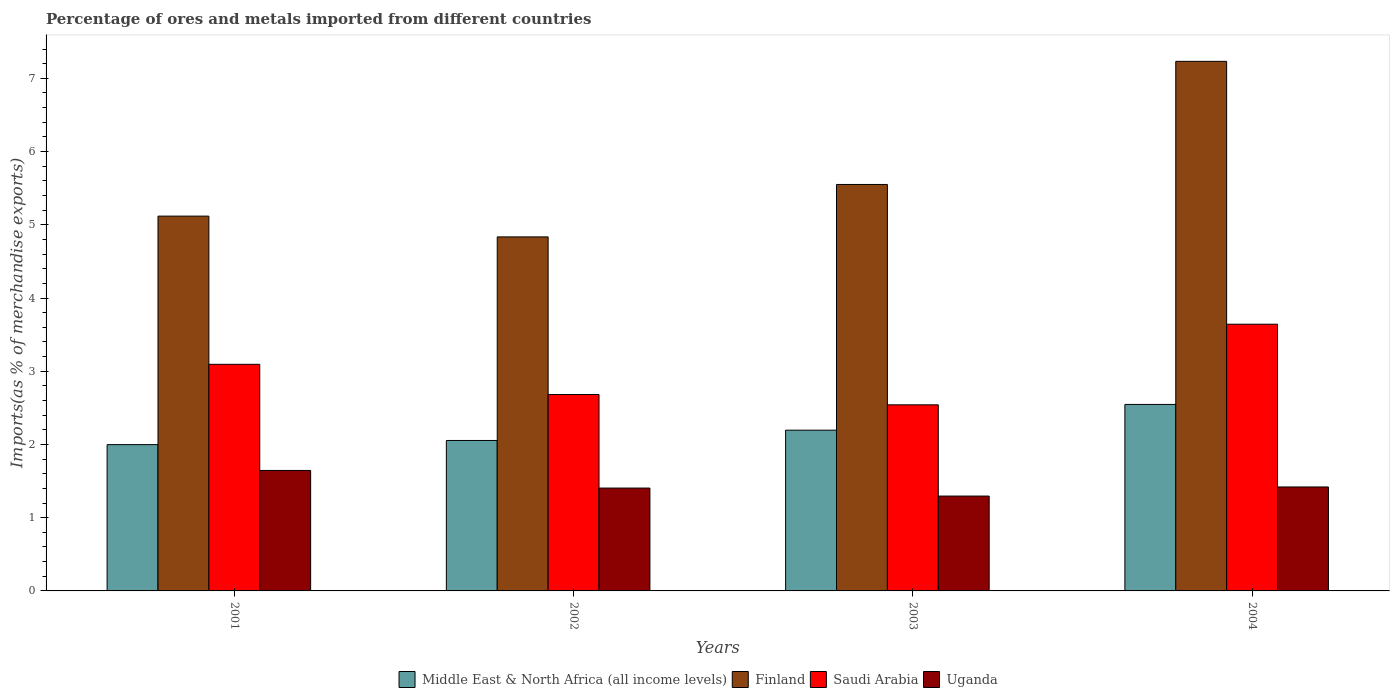How many bars are there on the 3rd tick from the left?
Your response must be concise. 4. What is the percentage of imports to different countries in Uganda in 2004?
Provide a succinct answer. 1.42. Across all years, what is the maximum percentage of imports to different countries in Finland?
Your answer should be very brief. 7.23. Across all years, what is the minimum percentage of imports to different countries in Middle East & North Africa (all income levels)?
Provide a succinct answer. 2. In which year was the percentage of imports to different countries in Finland maximum?
Your answer should be compact. 2004. In which year was the percentage of imports to different countries in Uganda minimum?
Your answer should be very brief. 2003. What is the total percentage of imports to different countries in Finland in the graph?
Ensure brevity in your answer.  22.74. What is the difference between the percentage of imports to different countries in Uganda in 2001 and that in 2003?
Ensure brevity in your answer.  0.35. What is the difference between the percentage of imports to different countries in Middle East & North Africa (all income levels) in 2003 and the percentage of imports to different countries in Uganda in 2002?
Offer a very short reply. 0.79. What is the average percentage of imports to different countries in Saudi Arabia per year?
Offer a terse response. 2.99. In the year 2003, what is the difference between the percentage of imports to different countries in Uganda and percentage of imports to different countries in Middle East & North Africa (all income levels)?
Ensure brevity in your answer.  -0.9. What is the ratio of the percentage of imports to different countries in Uganda in 2001 to that in 2003?
Provide a succinct answer. 1.27. Is the difference between the percentage of imports to different countries in Uganda in 2003 and 2004 greater than the difference between the percentage of imports to different countries in Middle East & North Africa (all income levels) in 2003 and 2004?
Make the answer very short. Yes. What is the difference between the highest and the second highest percentage of imports to different countries in Finland?
Provide a succinct answer. 1.68. What is the difference between the highest and the lowest percentage of imports to different countries in Uganda?
Your answer should be compact. 0.35. In how many years, is the percentage of imports to different countries in Finland greater than the average percentage of imports to different countries in Finland taken over all years?
Offer a terse response. 1. What does the 4th bar from the left in 2001 represents?
Provide a succinct answer. Uganda. What does the 2nd bar from the right in 2004 represents?
Your answer should be compact. Saudi Arabia. Is it the case that in every year, the sum of the percentage of imports to different countries in Saudi Arabia and percentage of imports to different countries in Uganda is greater than the percentage of imports to different countries in Finland?
Keep it short and to the point. No. How many bars are there?
Your answer should be very brief. 16. What is the difference between two consecutive major ticks on the Y-axis?
Provide a short and direct response. 1. Does the graph contain any zero values?
Your answer should be very brief. No. How are the legend labels stacked?
Make the answer very short. Horizontal. What is the title of the graph?
Your answer should be very brief. Percentage of ores and metals imported from different countries. What is the label or title of the X-axis?
Your answer should be compact. Years. What is the label or title of the Y-axis?
Provide a short and direct response. Imports(as % of merchandise exports). What is the Imports(as % of merchandise exports) in Middle East & North Africa (all income levels) in 2001?
Provide a short and direct response. 2. What is the Imports(as % of merchandise exports) of Finland in 2001?
Your response must be concise. 5.12. What is the Imports(as % of merchandise exports) of Saudi Arabia in 2001?
Ensure brevity in your answer.  3.09. What is the Imports(as % of merchandise exports) in Uganda in 2001?
Offer a very short reply. 1.65. What is the Imports(as % of merchandise exports) of Middle East & North Africa (all income levels) in 2002?
Your answer should be very brief. 2.05. What is the Imports(as % of merchandise exports) of Finland in 2002?
Your answer should be compact. 4.83. What is the Imports(as % of merchandise exports) in Saudi Arabia in 2002?
Keep it short and to the point. 2.68. What is the Imports(as % of merchandise exports) in Uganda in 2002?
Your response must be concise. 1.4. What is the Imports(as % of merchandise exports) of Middle East & North Africa (all income levels) in 2003?
Provide a short and direct response. 2.2. What is the Imports(as % of merchandise exports) in Finland in 2003?
Your answer should be very brief. 5.55. What is the Imports(as % of merchandise exports) in Saudi Arabia in 2003?
Offer a terse response. 2.54. What is the Imports(as % of merchandise exports) of Uganda in 2003?
Your answer should be very brief. 1.3. What is the Imports(as % of merchandise exports) of Middle East & North Africa (all income levels) in 2004?
Offer a terse response. 2.55. What is the Imports(as % of merchandise exports) in Finland in 2004?
Your answer should be compact. 7.23. What is the Imports(as % of merchandise exports) of Saudi Arabia in 2004?
Your answer should be compact. 3.64. What is the Imports(as % of merchandise exports) of Uganda in 2004?
Keep it short and to the point. 1.42. Across all years, what is the maximum Imports(as % of merchandise exports) in Middle East & North Africa (all income levels)?
Your response must be concise. 2.55. Across all years, what is the maximum Imports(as % of merchandise exports) of Finland?
Your answer should be very brief. 7.23. Across all years, what is the maximum Imports(as % of merchandise exports) in Saudi Arabia?
Give a very brief answer. 3.64. Across all years, what is the maximum Imports(as % of merchandise exports) of Uganda?
Your answer should be compact. 1.65. Across all years, what is the minimum Imports(as % of merchandise exports) in Middle East & North Africa (all income levels)?
Make the answer very short. 2. Across all years, what is the minimum Imports(as % of merchandise exports) of Finland?
Your answer should be very brief. 4.83. Across all years, what is the minimum Imports(as % of merchandise exports) of Saudi Arabia?
Your response must be concise. 2.54. Across all years, what is the minimum Imports(as % of merchandise exports) in Uganda?
Your response must be concise. 1.3. What is the total Imports(as % of merchandise exports) of Middle East & North Africa (all income levels) in the graph?
Ensure brevity in your answer.  8.79. What is the total Imports(as % of merchandise exports) of Finland in the graph?
Give a very brief answer. 22.74. What is the total Imports(as % of merchandise exports) of Saudi Arabia in the graph?
Your answer should be very brief. 11.96. What is the total Imports(as % of merchandise exports) of Uganda in the graph?
Make the answer very short. 5.76. What is the difference between the Imports(as % of merchandise exports) of Middle East & North Africa (all income levels) in 2001 and that in 2002?
Your response must be concise. -0.06. What is the difference between the Imports(as % of merchandise exports) of Finland in 2001 and that in 2002?
Keep it short and to the point. 0.28. What is the difference between the Imports(as % of merchandise exports) in Saudi Arabia in 2001 and that in 2002?
Provide a succinct answer. 0.41. What is the difference between the Imports(as % of merchandise exports) of Uganda in 2001 and that in 2002?
Keep it short and to the point. 0.24. What is the difference between the Imports(as % of merchandise exports) of Middle East & North Africa (all income levels) in 2001 and that in 2003?
Give a very brief answer. -0.2. What is the difference between the Imports(as % of merchandise exports) in Finland in 2001 and that in 2003?
Your response must be concise. -0.43. What is the difference between the Imports(as % of merchandise exports) in Saudi Arabia in 2001 and that in 2003?
Your answer should be very brief. 0.55. What is the difference between the Imports(as % of merchandise exports) of Middle East & North Africa (all income levels) in 2001 and that in 2004?
Keep it short and to the point. -0.55. What is the difference between the Imports(as % of merchandise exports) of Finland in 2001 and that in 2004?
Offer a very short reply. -2.11. What is the difference between the Imports(as % of merchandise exports) in Saudi Arabia in 2001 and that in 2004?
Ensure brevity in your answer.  -0.55. What is the difference between the Imports(as % of merchandise exports) of Uganda in 2001 and that in 2004?
Give a very brief answer. 0.23. What is the difference between the Imports(as % of merchandise exports) in Middle East & North Africa (all income levels) in 2002 and that in 2003?
Make the answer very short. -0.14. What is the difference between the Imports(as % of merchandise exports) in Finland in 2002 and that in 2003?
Provide a succinct answer. -0.72. What is the difference between the Imports(as % of merchandise exports) in Saudi Arabia in 2002 and that in 2003?
Make the answer very short. 0.14. What is the difference between the Imports(as % of merchandise exports) of Uganda in 2002 and that in 2003?
Ensure brevity in your answer.  0.11. What is the difference between the Imports(as % of merchandise exports) in Middle East & North Africa (all income levels) in 2002 and that in 2004?
Keep it short and to the point. -0.49. What is the difference between the Imports(as % of merchandise exports) of Finland in 2002 and that in 2004?
Ensure brevity in your answer.  -2.4. What is the difference between the Imports(as % of merchandise exports) of Saudi Arabia in 2002 and that in 2004?
Your answer should be compact. -0.96. What is the difference between the Imports(as % of merchandise exports) in Uganda in 2002 and that in 2004?
Offer a very short reply. -0.02. What is the difference between the Imports(as % of merchandise exports) of Middle East & North Africa (all income levels) in 2003 and that in 2004?
Offer a very short reply. -0.35. What is the difference between the Imports(as % of merchandise exports) in Finland in 2003 and that in 2004?
Provide a short and direct response. -1.68. What is the difference between the Imports(as % of merchandise exports) of Saudi Arabia in 2003 and that in 2004?
Your answer should be compact. -1.1. What is the difference between the Imports(as % of merchandise exports) of Uganda in 2003 and that in 2004?
Offer a terse response. -0.12. What is the difference between the Imports(as % of merchandise exports) in Middle East & North Africa (all income levels) in 2001 and the Imports(as % of merchandise exports) in Finland in 2002?
Your answer should be compact. -2.84. What is the difference between the Imports(as % of merchandise exports) in Middle East & North Africa (all income levels) in 2001 and the Imports(as % of merchandise exports) in Saudi Arabia in 2002?
Keep it short and to the point. -0.68. What is the difference between the Imports(as % of merchandise exports) of Middle East & North Africa (all income levels) in 2001 and the Imports(as % of merchandise exports) of Uganda in 2002?
Make the answer very short. 0.59. What is the difference between the Imports(as % of merchandise exports) in Finland in 2001 and the Imports(as % of merchandise exports) in Saudi Arabia in 2002?
Your response must be concise. 2.44. What is the difference between the Imports(as % of merchandise exports) in Finland in 2001 and the Imports(as % of merchandise exports) in Uganda in 2002?
Provide a short and direct response. 3.71. What is the difference between the Imports(as % of merchandise exports) of Saudi Arabia in 2001 and the Imports(as % of merchandise exports) of Uganda in 2002?
Offer a very short reply. 1.69. What is the difference between the Imports(as % of merchandise exports) in Middle East & North Africa (all income levels) in 2001 and the Imports(as % of merchandise exports) in Finland in 2003?
Ensure brevity in your answer.  -3.55. What is the difference between the Imports(as % of merchandise exports) of Middle East & North Africa (all income levels) in 2001 and the Imports(as % of merchandise exports) of Saudi Arabia in 2003?
Your answer should be compact. -0.54. What is the difference between the Imports(as % of merchandise exports) in Middle East & North Africa (all income levels) in 2001 and the Imports(as % of merchandise exports) in Uganda in 2003?
Your answer should be compact. 0.7. What is the difference between the Imports(as % of merchandise exports) of Finland in 2001 and the Imports(as % of merchandise exports) of Saudi Arabia in 2003?
Offer a terse response. 2.58. What is the difference between the Imports(as % of merchandise exports) of Finland in 2001 and the Imports(as % of merchandise exports) of Uganda in 2003?
Offer a very short reply. 3.82. What is the difference between the Imports(as % of merchandise exports) in Saudi Arabia in 2001 and the Imports(as % of merchandise exports) in Uganda in 2003?
Offer a very short reply. 1.8. What is the difference between the Imports(as % of merchandise exports) in Middle East & North Africa (all income levels) in 2001 and the Imports(as % of merchandise exports) in Finland in 2004?
Give a very brief answer. -5.23. What is the difference between the Imports(as % of merchandise exports) in Middle East & North Africa (all income levels) in 2001 and the Imports(as % of merchandise exports) in Saudi Arabia in 2004?
Offer a terse response. -1.64. What is the difference between the Imports(as % of merchandise exports) of Middle East & North Africa (all income levels) in 2001 and the Imports(as % of merchandise exports) of Uganda in 2004?
Offer a terse response. 0.58. What is the difference between the Imports(as % of merchandise exports) in Finland in 2001 and the Imports(as % of merchandise exports) in Saudi Arabia in 2004?
Ensure brevity in your answer.  1.48. What is the difference between the Imports(as % of merchandise exports) in Finland in 2001 and the Imports(as % of merchandise exports) in Uganda in 2004?
Keep it short and to the point. 3.7. What is the difference between the Imports(as % of merchandise exports) in Saudi Arabia in 2001 and the Imports(as % of merchandise exports) in Uganda in 2004?
Your response must be concise. 1.67. What is the difference between the Imports(as % of merchandise exports) of Middle East & North Africa (all income levels) in 2002 and the Imports(as % of merchandise exports) of Finland in 2003?
Provide a succinct answer. -3.5. What is the difference between the Imports(as % of merchandise exports) in Middle East & North Africa (all income levels) in 2002 and the Imports(as % of merchandise exports) in Saudi Arabia in 2003?
Your response must be concise. -0.49. What is the difference between the Imports(as % of merchandise exports) of Middle East & North Africa (all income levels) in 2002 and the Imports(as % of merchandise exports) of Uganda in 2003?
Your response must be concise. 0.76. What is the difference between the Imports(as % of merchandise exports) of Finland in 2002 and the Imports(as % of merchandise exports) of Saudi Arabia in 2003?
Give a very brief answer. 2.29. What is the difference between the Imports(as % of merchandise exports) in Finland in 2002 and the Imports(as % of merchandise exports) in Uganda in 2003?
Provide a succinct answer. 3.54. What is the difference between the Imports(as % of merchandise exports) of Saudi Arabia in 2002 and the Imports(as % of merchandise exports) of Uganda in 2003?
Ensure brevity in your answer.  1.39. What is the difference between the Imports(as % of merchandise exports) of Middle East & North Africa (all income levels) in 2002 and the Imports(as % of merchandise exports) of Finland in 2004?
Offer a terse response. -5.18. What is the difference between the Imports(as % of merchandise exports) in Middle East & North Africa (all income levels) in 2002 and the Imports(as % of merchandise exports) in Saudi Arabia in 2004?
Make the answer very short. -1.59. What is the difference between the Imports(as % of merchandise exports) in Middle East & North Africa (all income levels) in 2002 and the Imports(as % of merchandise exports) in Uganda in 2004?
Offer a very short reply. 0.63. What is the difference between the Imports(as % of merchandise exports) of Finland in 2002 and the Imports(as % of merchandise exports) of Saudi Arabia in 2004?
Offer a terse response. 1.19. What is the difference between the Imports(as % of merchandise exports) in Finland in 2002 and the Imports(as % of merchandise exports) in Uganda in 2004?
Provide a succinct answer. 3.41. What is the difference between the Imports(as % of merchandise exports) in Saudi Arabia in 2002 and the Imports(as % of merchandise exports) in Uganda in 2004?
Give a very brief answer. 1.26. What is the difference between the Imports(as % of merchandise exports) of Middle East & North Africa (all income levels) in 2003 and the Imports(as % of merchandise exports) of Finland in 2004?
Your answer should be compact. -5.04. What is the difference between the Imports(as % of merchandise exports) of Middle East & North Africa (all income levels) in 2003 and the Imports(as % of merchandise exports) of Saudi Arabia in 2004?
Provide a succinct answer. -1.45. What is the difference between the Imports(as % of merchandise exports) in Middle East & North Africa (all income levels) in 2003 and the Imports(as % of merchandise exports) in Uganda in 2004?
Your answer should be compact. 0.78. What is the difference between the Imports(as % of merchandise exports) of Finland in 2003 and the Imports(as % of merchandise exports) of Saudi Arabia in 2004?
Your answer should be compact. 1.91. What is the difference between the Imports(as % of merchandise exports) in Finland in 2003 and the Imports(as % of merchandise exports) in Uganda in 2004?
Your answer should be very brief. 4.13. What is the difference between the Imports(as % of merchandise exports) of Saudi Arabia in 2003 and the Imports(as % of merchandise exports) of Uganda in 2004?
Your response must be concise. 1.12. What is the average Imports(as % of merchandise exports) in Middle East & North Africa (all income levels) per year?
Ensure brevity in your answer.  2.2. What is the average Imports(as % of merchandise exports) in Finland per year?
Provide a short and direct response. 5.68. What is the average Imports(as % of merchandise exports) of Saudi Arabia per year?
Keep it short and to the point. 2.99. What is the average Imports(as % of merchandise exports) in Uganda per year?
Your answer should be very brief. 1.44. In the year 2001, what is the difference between the Imports(as % of merchandise exports) of Middle East & North Africa (all income levels) and Imports(as % of merchandise exports) of Finland?
Make the answer very short. -3.12. In the year 2001, what is the difference between the Imports(as % of merchandise exports) of Middle East & North Africa (all income levels) and Imports(as % of merchandise exports) of Saudi Arabia?
Ensure brevity in your answer.  -1.1. In the year 2001, what is the difference between the Imports(as % of merchandise exports) of Middle East & North Africa (all income levels) and Imports(as % of merchandise exports) of Uganda?
Provide a succinct answer. 0.35. In the year 2001, what is the difference between the Imports(as % of merchandise exports) in Finland and Imports(as % of merchandise exports) in Saudi Arabia?
Offer a terse response. 2.02. In the year 2001, what is the difference between the Imports(as % of merchandise exports) of Finland and Imports(as % of merchandise exports) of Uganda?
Offer a terse response. 3.47. In the year 2001, what is the difference between the Imports(as % of merchandise exports) of Saudi Arabia and Imports(as % of merchandise exports) of Uganda?
Provide a succinct answer. 1.45. In the year 2002, what is the difference between the Imports(as % of merchandise exports) of Middle East & North Africa (all income levels) and Imports(as % of merchandise exports) of Finland?
Provide a short and direct response. -2.78. In the year 2002, what is the difference between the Imports(as % of merchandise exports) of Middle East & North Africa (all income levels) and Imports(as % of merchandise exports) of Saudi Arabia?
Your response must be concise. -0.63. In the year 2002, what is the difference between the Imports(as % of merchandise exports) in Middle East & North Africa (all income levels) and Imports(as % of merchandise exports) in Uganda?
Offer a terse response. 0.65. In the year 2002, what is the difference between the Imports(as % of merchandise exports) of Finland and Imports(as % of merchandise exports) of Saudi Arabia?
Provide a short and direct response. 2.15. In the year 2002, what is the difference between the Imports(as % of merchandise exports) of Finland and Imports(as % of merchandise exports) of Uganda?
Your answer should be very brief. 3.43. In the year 2002, what is the difference between the Imports(as % of merchandise exports) in Saudi Arabia and Imports(as % of merchandise exports) in Uganda?
Keep it short and to the point. 1.28. In the year 2003, what is the difference between the Imports(as % of merchandise exports) of Middle East & North Africa (all income levels) and Imports(as % of merchandise exports) of Finland?
Your response must be concise. -3.36. In the year 2003, what is the difference between the Imports(as % of merchandise exports) in Middle East & North Africa (all income levels) and Imports(as % of merchandise exports) in Saudi Arabia?
Provide a short and direct response. -0.35. In the year 2003, what is the difference between the Imports(as % of merchandise exports) of Middle East & North Africa (all income levels) and Imports(as % of merchandise exports) of Uganda?
Your answer should be compact. 0.9. In the year 2003, what is the difference between the Imports(as % of merchandise exports) of Finland and Imports(as % of merchandise exports) of Saudi Arabia?
Offer a terse response. 3.01. In the year 2003, what is the difference between the Imports(as % of merchandise exports) in Finland and Imports(as % of merchandise exports) in Uganda?
Offer a terse response. 4.26. In the year 2003, what is the difference between the Imports(as % of merchandise exports) in Saudi Arabia and Imports(as % of merchandise exports) in Uganda?
Ensure brevity in your answer.  1.25. In the year 2004, what is the difference between the Imports(as % of merchandise exports) in Middle East & North Africa (all income levels) and Imports(as % of merchandise exports) in Finland?
Provide a succinct answer. -4.69. In the year 2004, what is the difference between the Imports(as % of merchandise exports) of Middle East & North Africa (all income levels) and Imports(as % of merchandise exports) of Saudi Arabia?
Your answer should be very brief. -1.1. In the year 2004, what is the difference between the Imports(as % of merchandise exports) in Middle East & North Africa (all income levels) and Imports(as % of merchandise exports) in Uganda?
Keep it short and to the point. 1.13. In the year 2004, what is the difference between the Imports(as % of merchandise exports) in Finland and Imports(as % of merchandise exports) in Saudi Arabia?
Offer a terse response. 3.59. In the year 2004, what is the difference between the Imports(as % of merchandise exports) in Finland and Imports(as % of merchandise exports) in Uganda?
Give a very brief answer. 5.81. In the year 2004, what is the difference between the Imports(as % of merchandise exports) of Saudi Arabia and Imports(as % of merchandise exports) of Uganda?
Provide a short and direct response. 2.22. What is the ratio of the Imports(as % of merchandise exports) in Middle East & North Africa (all income levels) in 2001 to that in 2002?
Provide a short and direct response. 0.97. What is the ratio of the Imports(as % of merchandise exports) in Finland in 2001 to that in 2002?
Keep it short and to the point. 1.06. What is the ratio of the Imports(as % of merchandise exports) in Saudi Arabia in 2001 to that in 2002?
Offer a very short reply. 1.15. What is the ratio of the Imports(as % of merchandise exports) in Uganda in 2001 to that in 2002?
Provide a succinct answer. 1.17. What is the ratio of the Imports(as % of merchandise exports) of Middle East & North Africa (all income levels) in 2001 to that in 2003?
Keep it short and to the point. 0.91. What is the ratio of the Imports(as % of merchandise exports) in Finland in 2001 to that in 2003?
Keep it short and to the point. 0.92. What is the ratio of the Imports(as % of merchandise exports) of Saudi Arabia in 2001 to that in 2003?
Provide a succinct answer. 1.22. What is the ratio of the Imports(as % of merchandise exports) of Uganda in 2001 to that in 2003?
Give a very brief answer. 1.27. What is the ratio of the Imports(as % of merchandise exports) of Middle East & North Africa (all income levels) in 2001 to that in 2004?
Offer a terse response. 0.78. What is the ratio of the Imports(as % of merchandise exports) of Finland in 2001 to that in 2004?
Your answer should be very brief. 0.71. What is the ratio of the Imports(as % of merchandise exports) of Saudi Arabia in 2001 to that in 2004?
Your answer should be compact. 0.85. What is the ratio of the Imports(as % of merchandise exports) in Uganda in 2001 to that in 2004?
Make the answer very short. 1.16. What is the ratio of the Imports(as % of merchandise exports) of Middle East & North Africa (all income levels) in 2002 to that in 2003?
Provide a succinct answer. 0.94. What is the ratio of the Imports(as % of merchandise exports) in Finland in 2002 to that in 2003?
Offer a terse response. 0.87. What is the ratio of the Imports(as % of merchandise exports) in Saudi Arabia in 2002 to that in 2003?
Your answer should be very brief. 1.06. What is the ratio of the Imports(as % of merchandise exports) of Uganda in 2002 to that in 2003?
Provide a short and direct response. 1.08. What is the ratio of the Imports(as % of merchandise exports) of Middle East & North Africa (all income levels) in 2002 to that in 2004?
Your answer should be very brief. 0.81. What is the ratio of the Imports(as % of merchandise exports) of Finland in 2002 to that in 2004?
Your answer should be compact. 0.67. What is the ratio of the Imports(as % of merchandise exports) in Saudi Arabia in 2002 to that in 2004?
Your answer should be very brief. 0.74. What is the ratio of the Imports(as % of merchandise exports) in Uganda in 2002 to that in 2004?
Offer a terse response. 0.99. What is the ratio of the Imports(as % of merchandise exports) in Middle East & North Africa (all income levels) in 2003 to that in 2004?
Keep it short and to the point. 0.86. What is the ratio of the Imports(as % of merchandise exports) of Finland in 2003 to that in 2004?
Make the answer very short. 0.77. What is the ratio of the Imports(as % of merchandise exports) in Saudi Arabia in 2003 to that in 2004?
Give a very brief answer. 0.7. What is the ratio of the Imports(as % of merchandise exports) of Uganda in 2003 to that in 2004?
Give a very brief answer. 0.91. What is the difference between the highest and the second highest Imports(as % of merchandise exports) in Middle East & North Africa (all income levels)?
Your response must be concise. 0.35. What is the difference between the highest and the second highest Imports(as % of merchandise exports) of Finland?
Your answer should be very brief. 1.68. What is the difference between the highest and the second highest Imports(as % of merchandise exports) in Saudi Arabia?
Keep it short and to the point. 0.55. What is the difference between the highest and the second highest Imports(as % of merchandise exports) of Uganda?
Ensure brevity in your answer.  0.23. What is the difference between the highest and the lowest Imports(as % of merchandise exports) in Middle East & North Africa (all income levels)?
Offer a very short reply. 0.55. What is the difference between the highest and the lowest Imports(as % of merchandise exports) in Finland?
Keep it short and to the point. 2.4. What is the difference between the highest and the lowest Imports(as % of merchandise exports) of Saudi Arabia?
Make the answer very short. 1.1. What is the difference between the highest and the lowest Imports(as % of merchandise exports) in Uganda?
Make the answer very short. 0.35. 